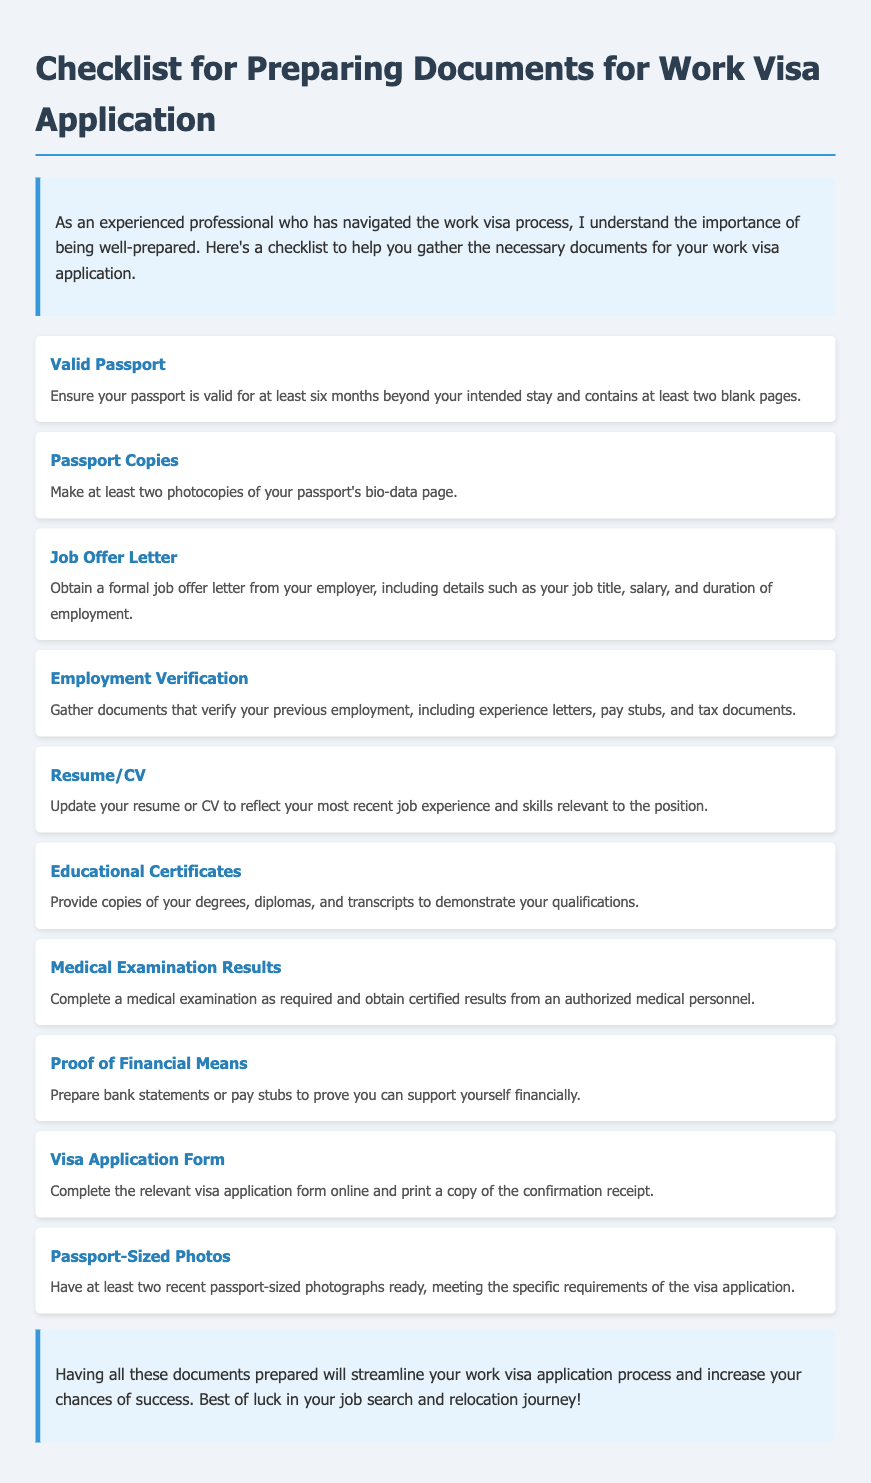What is the title of the document? The title of the document is presented prominently at the top of the content, giving a clear indication of its purpose.
Answer: Checklist for Preparing Documents for Work Visa Application How many passport copies are required? The document specifies the number of passport copies required under the item for passport copies.
Answer: Two What is included in the job offer letter? The details required in the job offer letter are outlined in the corresponding checklist item.
Answer: Job title, salary, and duration of employment What should be updated before submitting? The document mentions updating a specific document type that is crucial for the application process.
Answer: Resume/CV What type of examination is required? The checklist item discusses the type of examination that applicants must complete before applying.
Answer: Medical examination What is one type of proof needed for financial means? The document states a specific kind of document that can serve as proof of financial stability.
Answer: Bank statements What needs to be completed online? The document lists a specific form type that must be completed via an online platform as part of the application process.
Answer: Visa application form How many passport-sized photos are required? The number of passport-sized photos that need to be prepared is clearly stated in one of the checklist items.
Answer: Two 